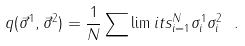<formula> <loc_0><loc_0><loc_500><loc_500>q ( \vec { \sigma } ^ { 1 } , \vec { \sigma } ^ { 2 } ) = \frac { 1 } { N } \sum \lim i t s _ { i = 1 } ^ { N } \sigma _ { i } ^ { 1 } \sigma _ { i } ^ { 2 } \ .</formula> 